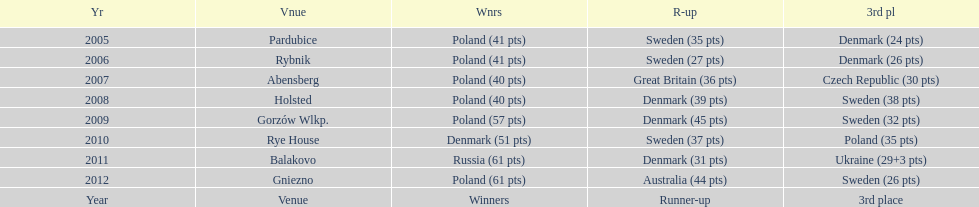When was the first year that poland did not place in the top three positions of the team speedway junior world championship? 2011. 